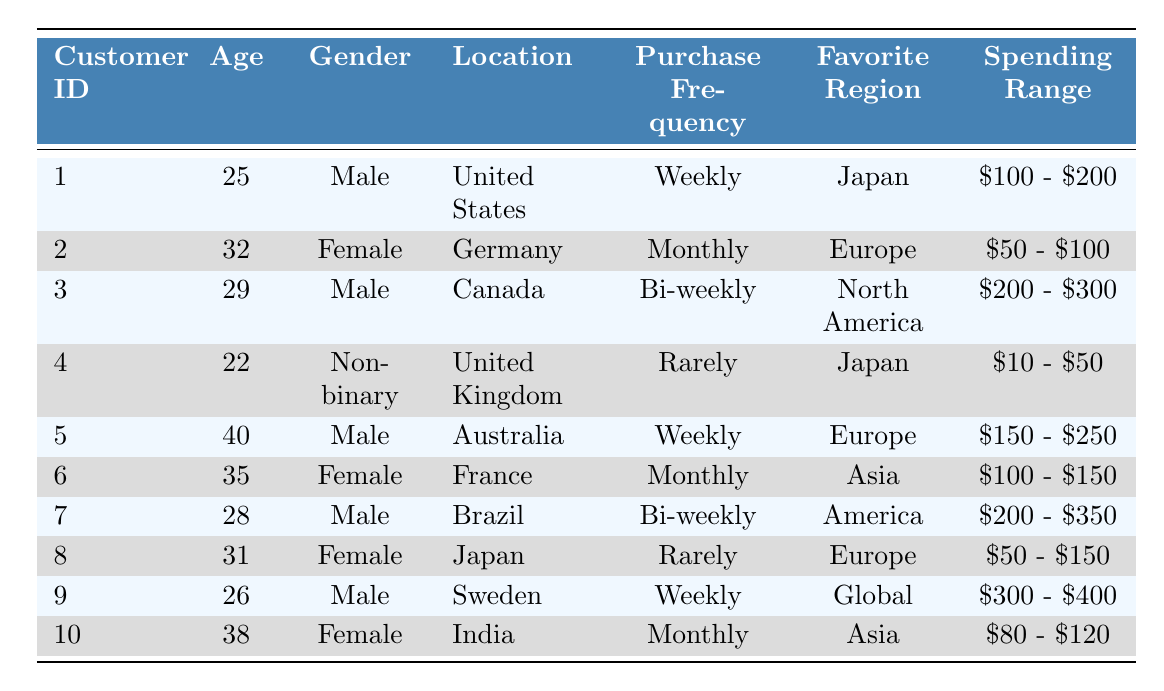What is the favorite region of customer 1? Customer 1's favorite region is listed directly in the table under the "Favorite Region" column, which shows "Japan".
Answer: Japan How many customers have a purchase frequency of "Monthly"? There are 3 customers in the table with a purchase frequency of "Monthly": customer 2, customer 6, and customer 10, which can be counted by looking at the "Purchase Frequency" column.
Answer: 3 Are there any customers who rarely purchase and also have a spending range of "$10 - $50"? Yes, customer 4 is identified in the table as having a purchase frequency of "Rarely" and a spending range of "$10 - $50", confirming a match on both criteria.
Answer: Yes What is the average age of customers who prefer the "Europe" region? First, we identify the customers who favor "Europe": customers 2, 5, and 8, with ages 32, 40, and 31 respectively. Their sum is 32 + 40 + 31 = 103. There are 3 customers, so the average age is 103/3 ≈ 34.33.
Answer: 34.33 How many different spending ranges are represented in the table? By assessing each entry in the "Spending Range" column, we find the unique ranges are "$10 - $50", "$50 - $100", "$80 - $120", "$100 - $150", "$100 - $200", "$150 - $250", "$200 - $300", "$200 - $350", and "$300 - $400", making a total of 9 unique spending ranges.
Answer: 9 Is customer 9 older than customer 7? Looking at the "Age" column, customer 9 is 26 years old and customer 7 is 28 years old. Since 26 is not greater than 28, the answer is no.
Answer: No What is the spending range of the customer with the highest age? Customer 5, who is the oldest at 40 years, has a spending range of "$150 - $250", which can be found by locating customer 5 in the table.
Answer: $150 - $250 Which gender has the most customers in the table? Evaluating the "Gender" column, there are 4 males, 4 females, and 1 non-binary, thus males and females have equal representation among the customers.
Answer: Equal What is the total number of customers who have a favorite region of "Asia" and a purchase frequency of "Monthly"? We check the entries for "Asia" and find 2 customers (6 and 10), with both having a purchase frequency of "Monthly", making the count 2.
Answer: 2 